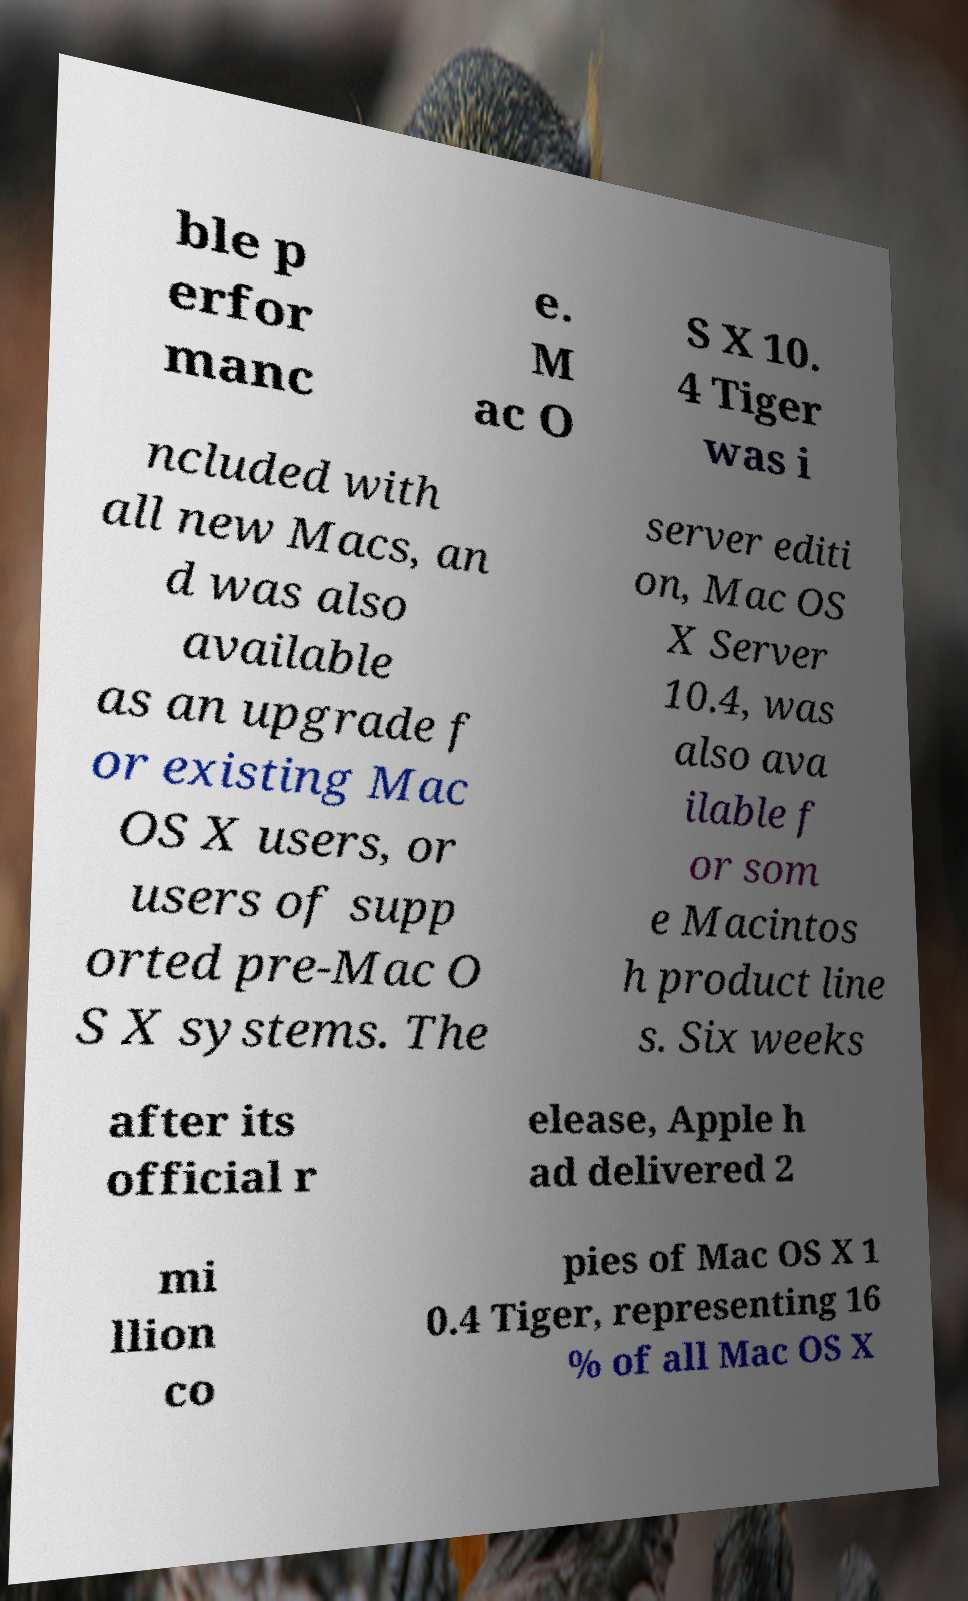There's text embedded in this image that I need extracted. Can you transcribe it verbatim? ble p erfor manc e. M ac O S X 10. 4 Tiger was i ncluded with all new Macs, an d was also available as an upgrade f or existing Mac OS X users, or users of supp orted pre-Mac O S X systems. The server editi on, Mac OS X Server 10.4, was also ava ilable f or som e Macintos h product line s. Six weeks after its official r elease, Apple h ad delivered 2 mi llion co pies of Mac OS X 1 0.4 Tiger, representing 16 % of all Mac OS X 